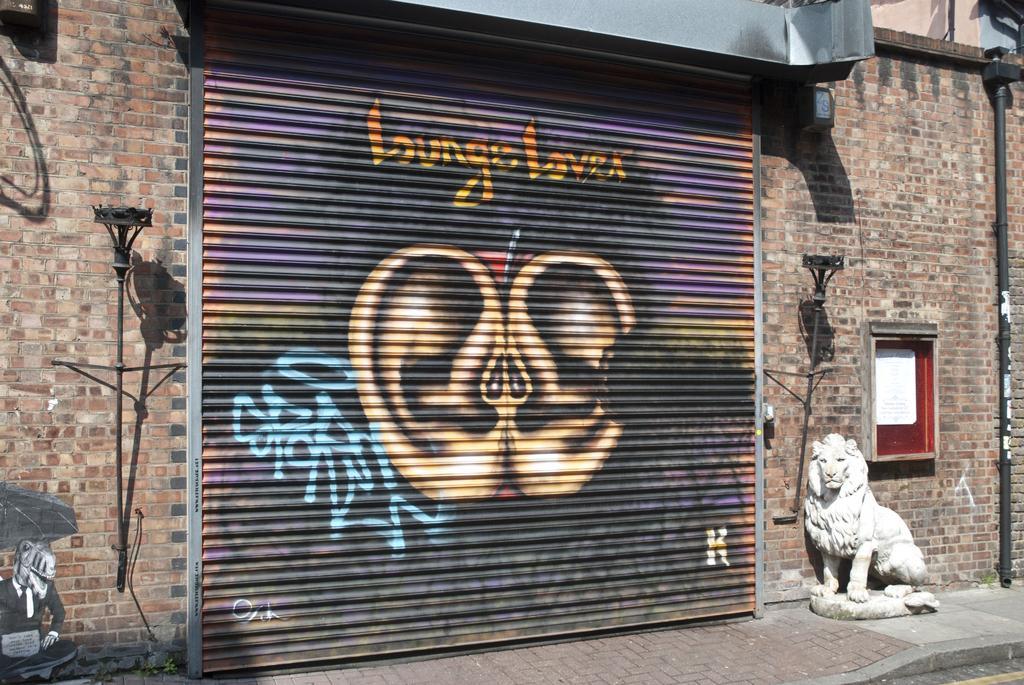Could you give a brief overview of what you see in this image? In this image, I can see graffiti on a rolling shutter and there are ancient torch holders, a board and a pipe attached to the wall. At the bottom of the image, I can see a statue of a lion. In the bottom left corner of the image, there is a painting on the wall. 